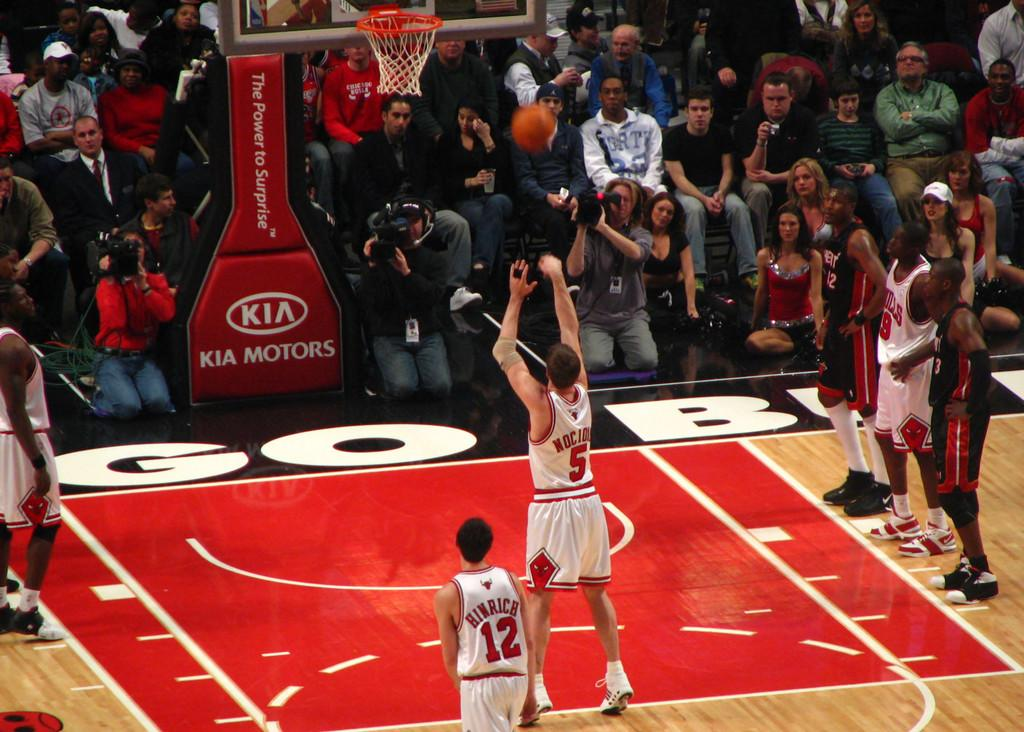<image>
Relay a brief, clear account of the picture shown. number 5 from the red and white team shooting a foul shot 